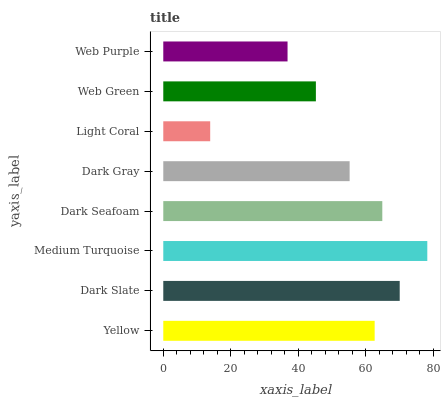Is Light Coral the minimum?
Answer yes or no. Yes. Is Medium Turquoise the maximum?
Answer yes or no. Yes. Is Dark Slate the minimum?
Answer yes or no. No. Is Dark Slate the maximum?
Answer yes or no. No. Is Dark Slate greater than Yellow?
Answer yes or no. Yes. Is Yellow less than Dark Slate?
Answer yes or no. Yes. Is Yellow greater than Dark Slate?
Answer yes or no. No. Is Dark Slate less than Yellow?
Answer yes or no. No. Is Yellow the high median?
Answer yes or no. Yes. Is Dark Gray the low median?
Answer yes or no. Yes. Is Web Purple the high median?
Answer yes or no. No. Is Dark Slate the low median?
Answer yes or no. No. 